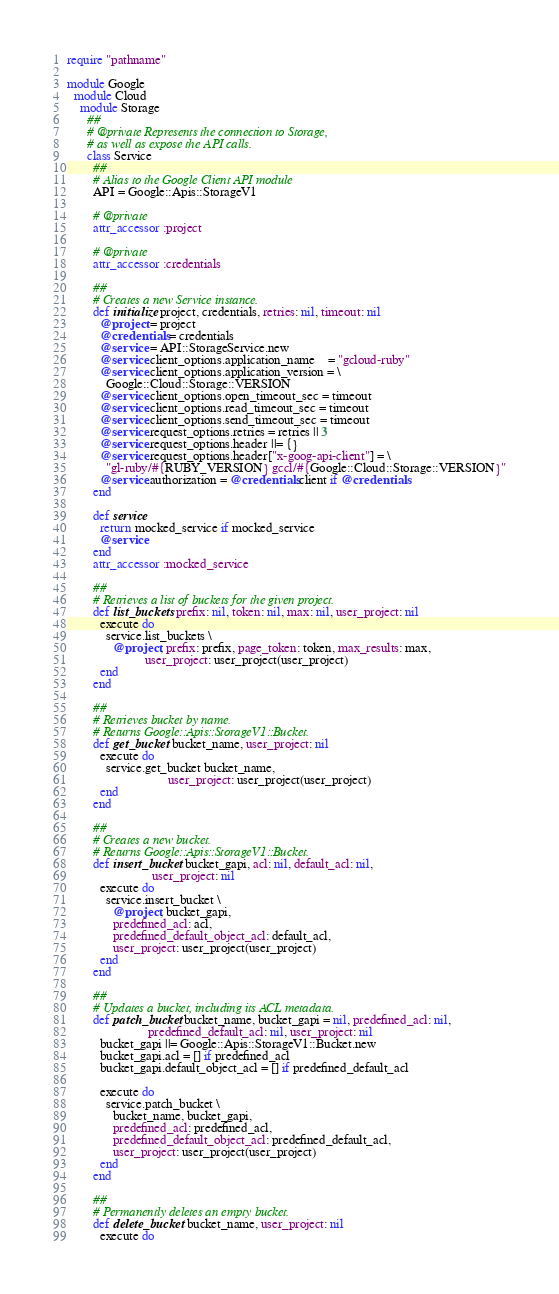<code> <loc_0><loc_0><loc_500><loc_500><_Ruby_>require "pathname"

module Google
  module Cloud
    module Storage
      ##
      # @private Represents the connection to Storage,
      # as well as expose the API calls.
      class Service
        ##
        # Alias to the Google Client API module
        API = Google::Apis::StorageV1

        # @private
        attr_accessor :project

        # @private
        attr_accessor :credentials

        ##
        # Creates a new Service instance.
        def initialize project, credentials, retries: nil, timeout: nil
          @project = project
          @credentials = credentials
          @service = API::StorageService.new
          @service.client_options.application_name    = "gcloud-ruby"
          @service.client_options.application_version = \
            Google::Cloud::Storage::VERSION
          @service.client_options.open_timeout_sec = timeout
          @service.client_options.read_timeout_sec = timeout
          @service.client_options.send_timeout_sec = timeout
          @service.request_options.retries = retries || 3
          @service.request_options.header ||= {}
          @service.request_options.header["x-goog-api-client"] = \
            "gl-ruby/#{RUBY_VERSION} gccl/#{Google::Cloud::Storage::VERSION}"
          @service.authorization = @credentials.client if @credentials
        end

        def service
          return mocked_service if mocked_service
          @service
        end
        attr_accessor :mocked_service

        ##
        # Retrieves a list of buckets for the given project.
        def list_buckets prefix: nil, token: nil, max: nil, user_project: nil
          execute do
            service.list_buckets \
              @project, prefix: prefix, page_token: token, max_results: max,
                        user_project: user_project(user_project)
          end
        end

        ##
        # Retrieves bucket by name.
        # Returns Google::Apis::StorageV1::Bucket.
        def get_bucket bucket_name, user_project: nil
          execute do
            service.get_bucket bucket_name,
                               user_project: user_project(user_project)
          end
        end

        ##
        # Creates a new bucket.
        # Returns Google::Apis::StorageV1::Bucket.
        def insert_bucket bucket_gapi, acl: nil, default_acl: nil,
                          user_project: nil
          execute do
            service.insert_bucket \
              @project, bucket_gapi,
              predefined_acl: acl,
              predefined_default_object_acl: default_acl,
              user_project: user_project(user_project)
          end
        end

        ##
        # Updates a bucket, including its ACL metadata.
        def patch_bucket bucket_name, bucket_gapi = nil, predefined_acl: nil,
                         predefined_default_acl: nil, user_project: nil
          bucket_gapi ||= Google::Apis::StorageV1::Bucket.new
          bucket_gapi.acl = [] if predefined_acl
          bucket_gapi.default_object_acl = [] if predefined_default_acl

          execute do
            service.patch_bucket \
              bucket_name, bucket_gapi,
              predefined_acl: predefined_acl,
              predefined_default_object_acl: predefined_default_acl,
              user_project: user_project(user_project)
          end
        end

        ##
        # Permanently deletes an empty bucket.
        def delete_bucket bucket_name, user_project: nil
          execute do</code> 